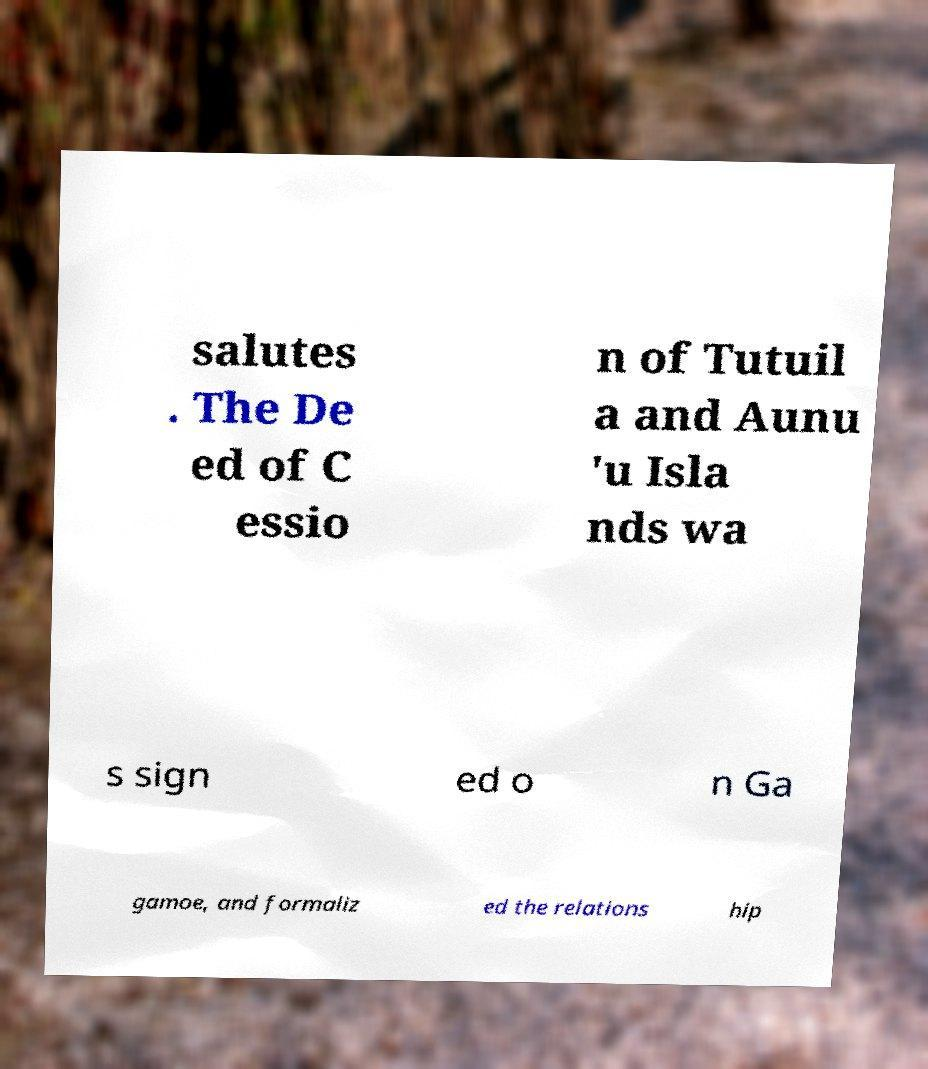Can you read and provide the text displayed in the image?This photo seems to have some interesting text. Can you extract and type it out for me? salutes . The De ed of C essio n of Tutuil a and Aunu 'u Isla nds wa s sign ed o n Ga gamoe, and formaliz ed the relations hip 